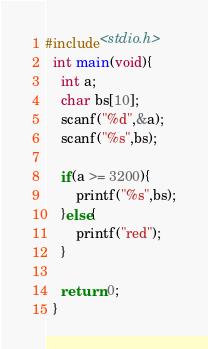<code> <loc_0><loc_0><loc_500><loc_500><_C_>#include<stdio.h>
  int main(void){
    int a;
    char bs[10];
    scanf("%d",&a);
    scanf("%s",bs);

    if(a >= 3200){
        printf("%s",bs);
    }else{
        printf("red");
    }   

    return 0;
  }


</code> 